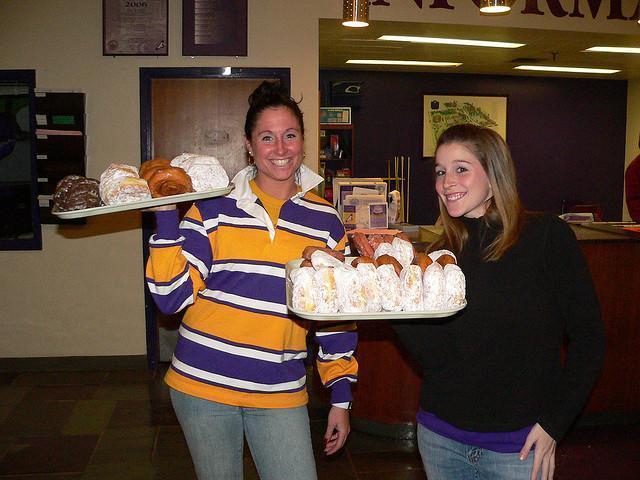How many people are there?
Give a very brief answer. 2. 